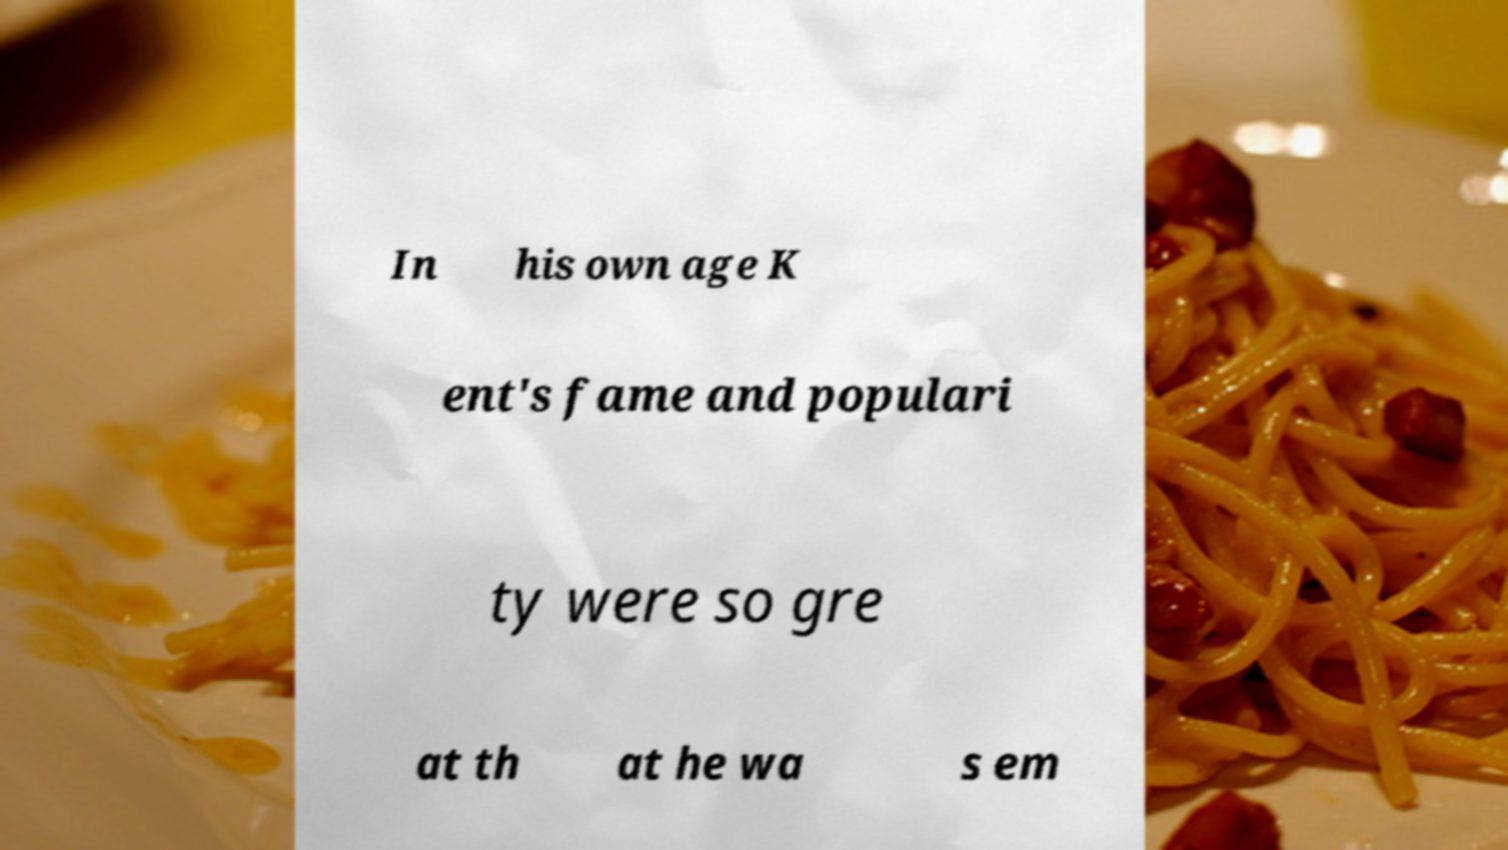I need the written content from this picture converted into text. Can you do that? In his own age K ent's fame and populari ty were so gre at th at he wa s em 